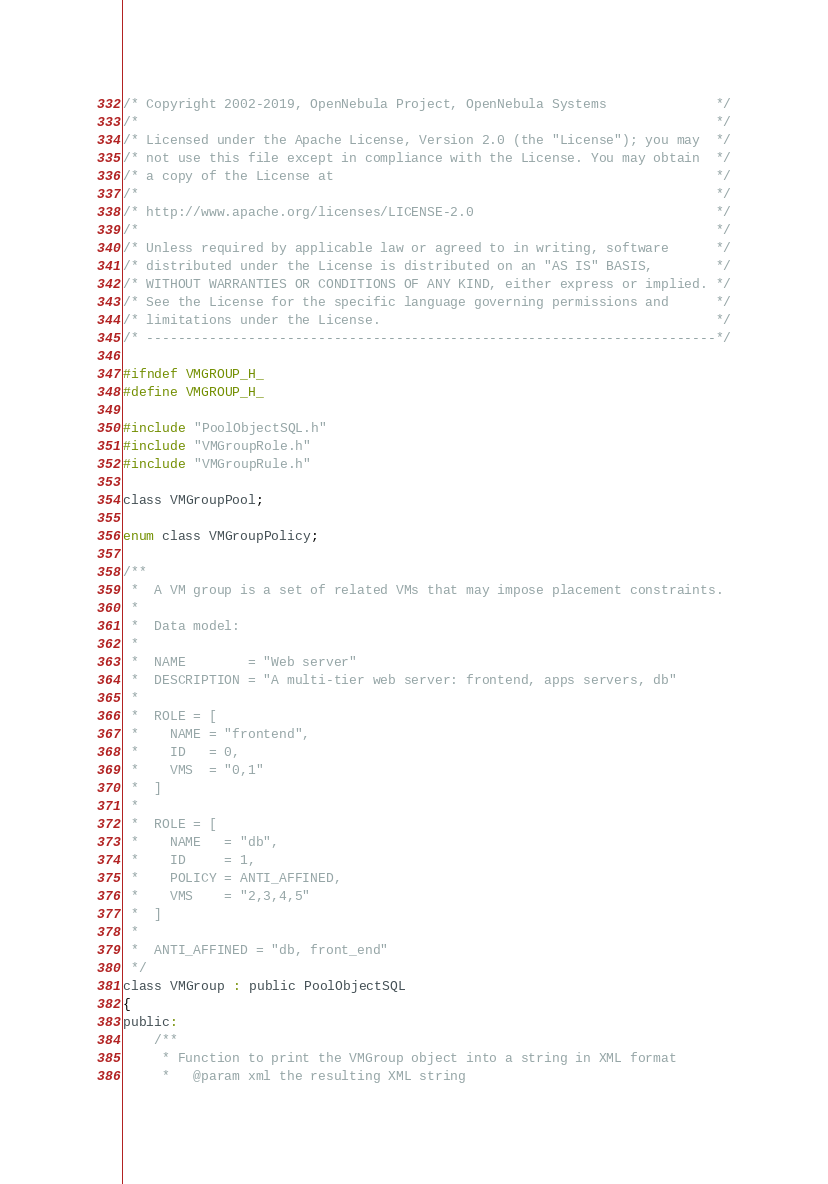<code> <loc_0><loc_0><loc_500><loc_500><_C_>/* Copyright 2002-2019, OpenNebula Project, OpenNebula Systems              */
/*                                                                          */
/* Licensed under the Apache License, Version 2.0 (the "License"); you may  */
/* not use this file except in compliance with the License. You may obtain  */
/* a copy of the License at                                                 */
/*                                                                          */
/* http://www.apache.org/licenses/LICENSE-2.0                               */
/*                                                                          */
/* Unless required by applicable law or agreed to in writing, software      */
/* distributed under the License is distributed on an "AS IS" BASIS,        */
/* WITHOUT WARRANTIES OR CONDITIONS OF ANY KIND, either express or implied. */
/* See the License for the specific language governing permissions and      */
/* limitations under the License.                                           */
/* -------------------------------------------------------------------------*/

#ifndef VMGROUP_H_
#define VMGROUP_H_

#include "PoolObjectSQL.h"
#include "VMGroupRole.h"
#include "VMGroupRule.h"

class VMGroupPool;

enum class VMGroupPolicy;

/**
 *  A VM group is a set of related VMs that may impose placement constraints.
 *
 *  Data model:
 *
 *  NAME        = "Web server"
 *  DESCRIPTION = "A multi-tier web server: frontend, apps servers, db"
 *
 *  ROLE = [
 *    NAME = "frontend",
 *    ID   = 0,
 *    VMS  = "0,1"
 *  ]
 *
 *  ROLE = [
 *    NAME   = "db",
 *    ID     = 1,
 *    POLICY = ANTI_AFFINED,
 *    VMS    = "2,3,4,5"
 *  ]
 *
 *  ANTI_AFFINED = "db, front_end"
 */
class VMGroup : public PoolObjectSQL
{
public:
    /**
     * Function to print the VMGroup object into a string in XML format
     *   @param xml the resulting XML string</code> 